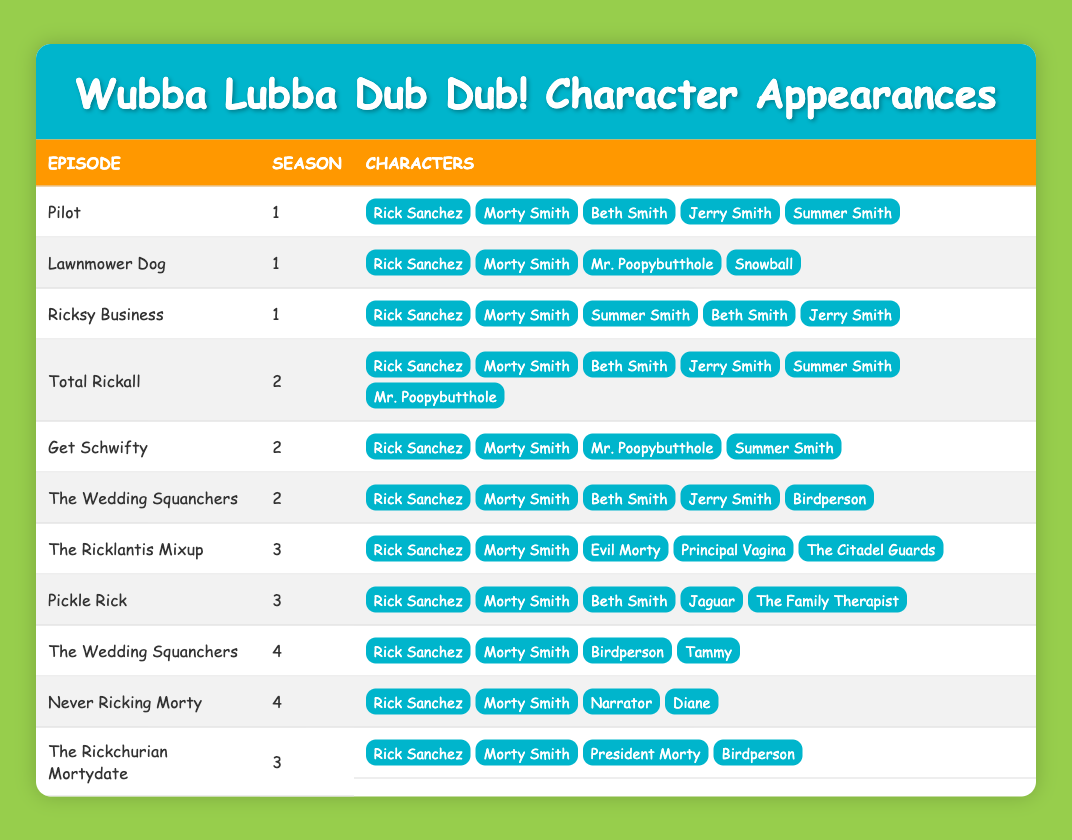What characters appear in the episode "Total Rickall"? In the row for "Total Rickall," the characters listed are Rick Sanchez, Morty Smith, Beth Smith, Jerry Smith, Summer Smith, and Mr. Poopybutthole.
Answer: Rick Sanchez, Morty Smith, Beth Smith, Jerry Smith, Summer Smith, Mr. Poopybutthole Which season features the most appearances by "Birdperson"? Looking through the episodes featuring Birdperson, they appear in "The Wedding Squanchers" for Season 2 and again in the same episode title for Season 4. This totals to 2 appearances across 2 different seasons.
Answer: 2 Does "Evil Morty" appear in Season 1? The table does not list Evil Morty in any episode of Season 1. The only season where Evil Morty appears is Season 3.
Answer: No How many episodes feature both Rick Sanchez and Morty Smith? Counting the episodes listed, Rick Sanchez and Morty Smith appear together in all episodes from Seasons 1 to 4: "Pilot," "Lawnmower Dog," "Ricksy Business," "Total Rickall," "Get Schwifty," "The Wedding Squanchers," "The Ricklantis Mixup," "Pickle Rick," and additionally in "Never Ricking Morty." This totals to 9 episodes.
Answer: 9 In which episodes does "Mr. Poopybutthole" appear? Mr. Poopybutthole appears in the episodes "Lawnmower Dog," "Total Rickall," and "Get Schwifty" from Seasons 1 and 2.
Answer: Lawn mower Dog, Total Rickall, Get Schwifty What is the average number of characters appearing per episode? There are 10 episodes listed, with a total of 41 character appearances. To find the average, divide 41 by 10, resulting in an average of 4.1 characters per episode.
Answer: 4.1 Which episode has the highest number of character appearances? In the episode "Total Rickall," there are 6 character appearances listed (Rick Sanchez, Morty Smith, Beth Smith, Jerry Smith, Summer Smith, Mr. Poopybutthole), which is the maximum in this dataset.
Answer: Total Rickall Is "Tammy" present in the first season of the show? Checking the entries, Tammy is only listed in the fourth season in the episode "The Wedding Squanchers," so she does not appear in Season 1.
Answer: No How many characters appear in the episode "Pickle Rick"? In "Pickle Rick," the characters mentioned are Rick Sanchez, Morty Smith, Beth Smith, Jaguar, and The Family Therapist, totaling 5 characters.
Answer: 5 